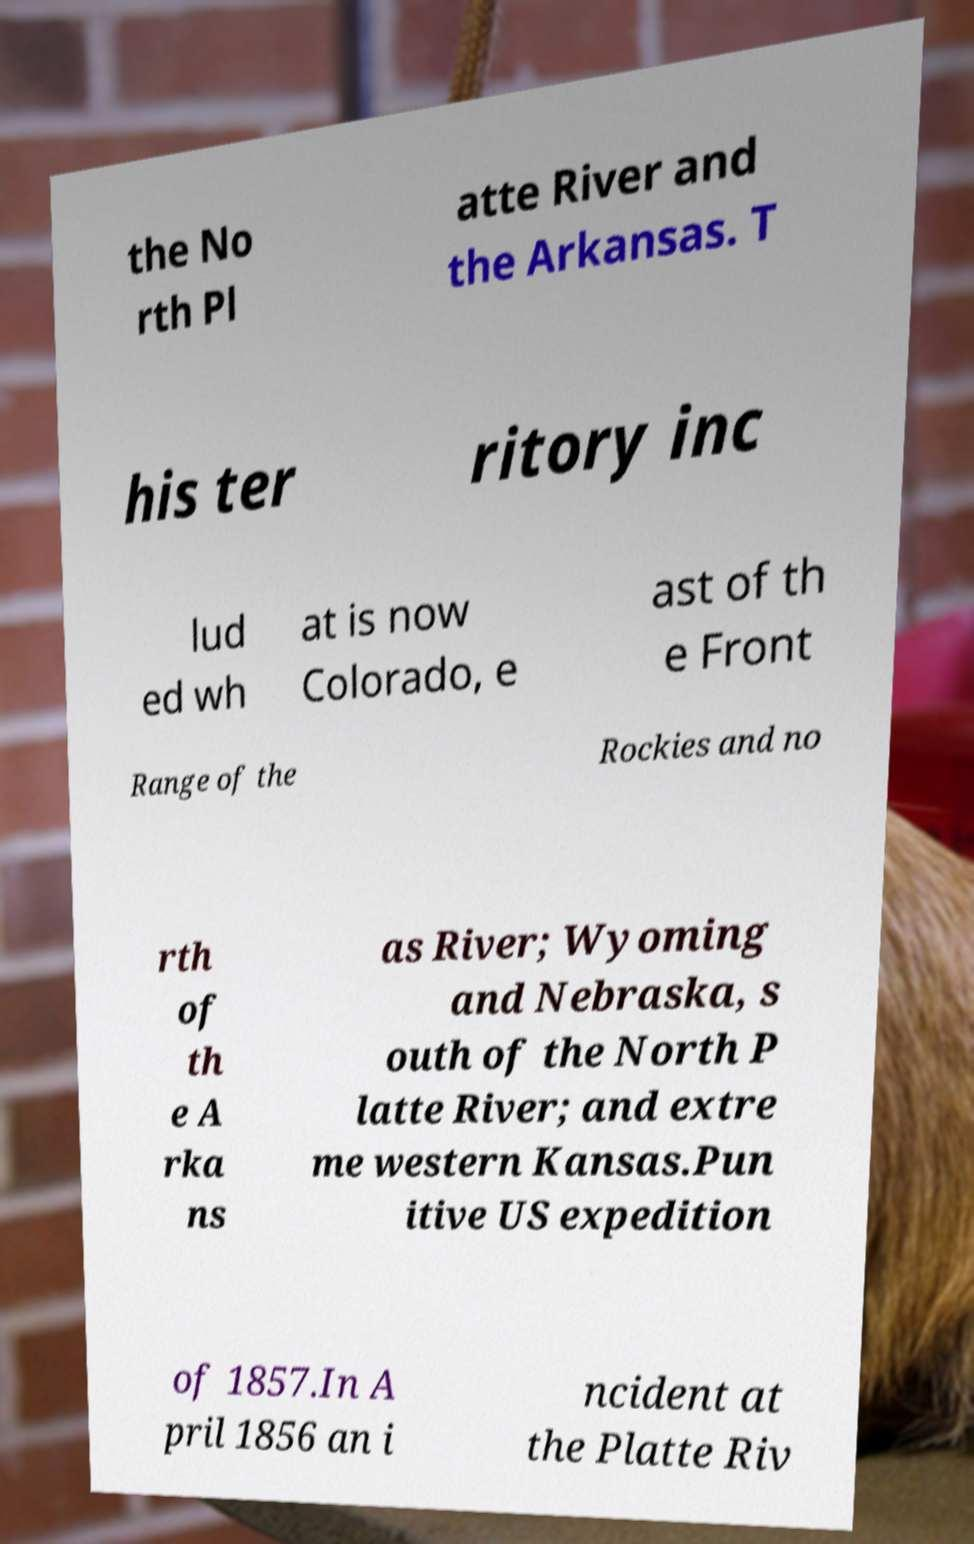Can you read and provide the text displayed in the image?This photo seems to have some interesting text. Can you extract and type it out for me? the No rth Pl atte River and the Arkansas. T his ter ritory inc lud ed wh at is now Colorado, e ast of th e Front Range of the Rockies and no rth of th e A rka ns as River; Wyoming and Nebraska, s outh of the North P latte River; and extre me western Kansas.Pun itive US expedition of 1857.In A pril 1856 an i ncident at the Platte Riv 